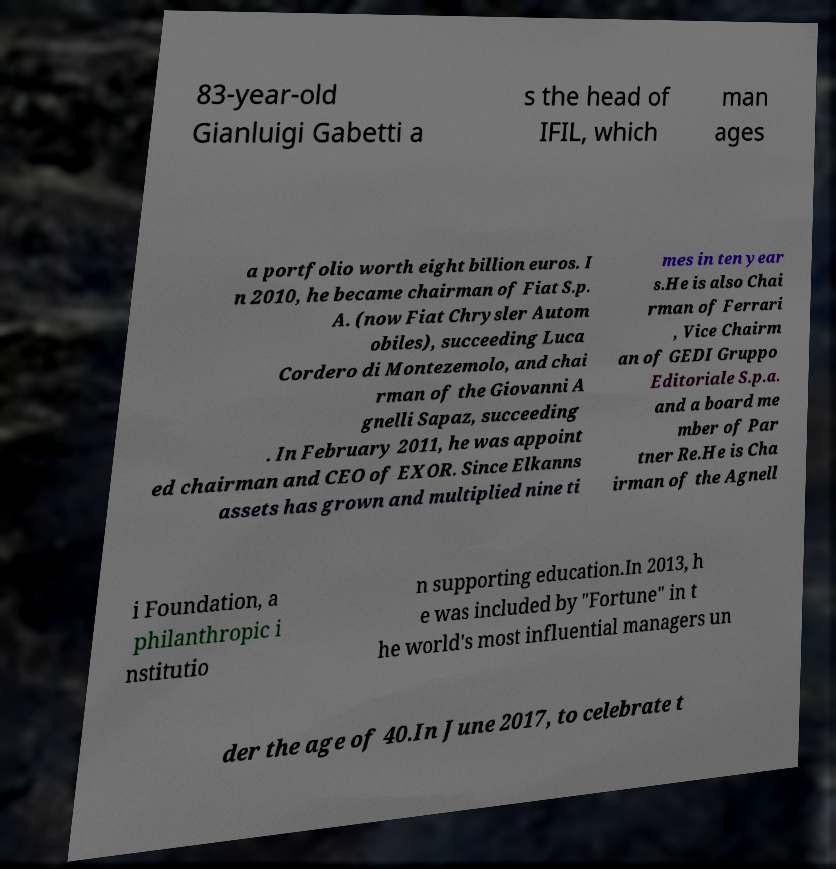Please identify and transcribe the text found in this image. 83-year-old Gianluigi Gabetti a s the head of IFIL, which man ages a portfolio worth eight billion euros. I n 2010, he became chairman of Fiat S.p. A. (now Fiat Chrysler Autom obiles), succeeding Luca Cordero di Montezemolo, and chai rman of the Giovanni A gnelli Sapaz, succeeding . In February 2011, he was appoint ed chairman and CEO of EXOR. Since Elkanns assets has grown and multiplied nine ti mes in ten year s.He is also Chai rman of Ferrari , Vice Chairm an of GEDI Gruppo Editoriale S.p.a. and a board me mber of Par tner Re.He is Cha irman of the Agnell i Foundation, a philanthropic i nstitutio n supporting education.In 2013, h e was included by "Fortune" in t he world's most influential managers un der the age of 40.In June 2017, to celebrate t 